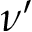Convert formula to latex. <formula><loc_0><loc_0><loc_500><loc_500>\nu ^ { \prime }</formula> 